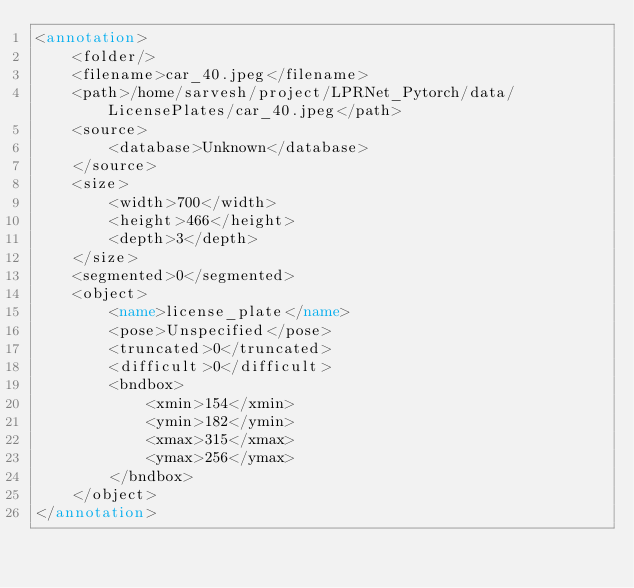<code> <loc_0><loc_0><loc_500><loc_500><_XML_><annotation>
	<folder/>
	<filename>car_40.jpeg</filename>
	<path>/home/sarvesh/project/LPRNet_Pytorch/data/LicensePlates/car_40.jpeg</path>
	<source>
		<database>Unknown</database>
	</source>
	<size>
		<width>700</width>
		<height>466</height>
		<depth>3</depth>
	</size>
	<segmented>0</segmented>
	<object>
		<name>license_plate</name>
		<pose>Unspecified</pose>
		<truncated>0</truncated>
		<difficult>0</difficult>
		<bndbox>
			<xmin>154</xmin>
			<ymin>182</ymin>
			<xmax>315</xmax>
			<ymax>256</ymax>
		</bndbox>
	</object>
</annotation>
</code> 